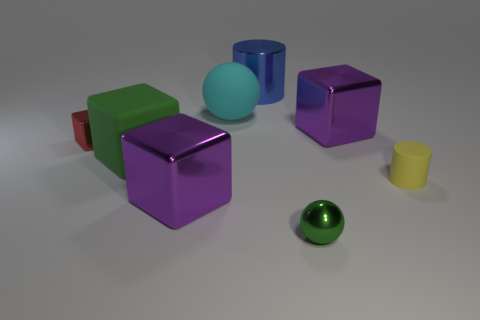Subtract all green rubber blocks. How many blocks are left? 3 Add 1 small blocks. How many objects exist? 9 Subtract all green balls. How many balls are left? 1 Subtract all cylinders. How many objects are left? 6 Subtract 2 spheres. How many spheres are left? 0 Subtract 1 red cubes. How many objects are left? 7 Subtract all blue cylinders. Subtract all green cubes. How many cylinders are left? 1 Subtract all brown balls. How many blue cylinders are left? 1 Subtract all brown objects. Subtract all purple things. How many objects are left? 6 Add 1 purple objects. How many purple objects are left? 3 